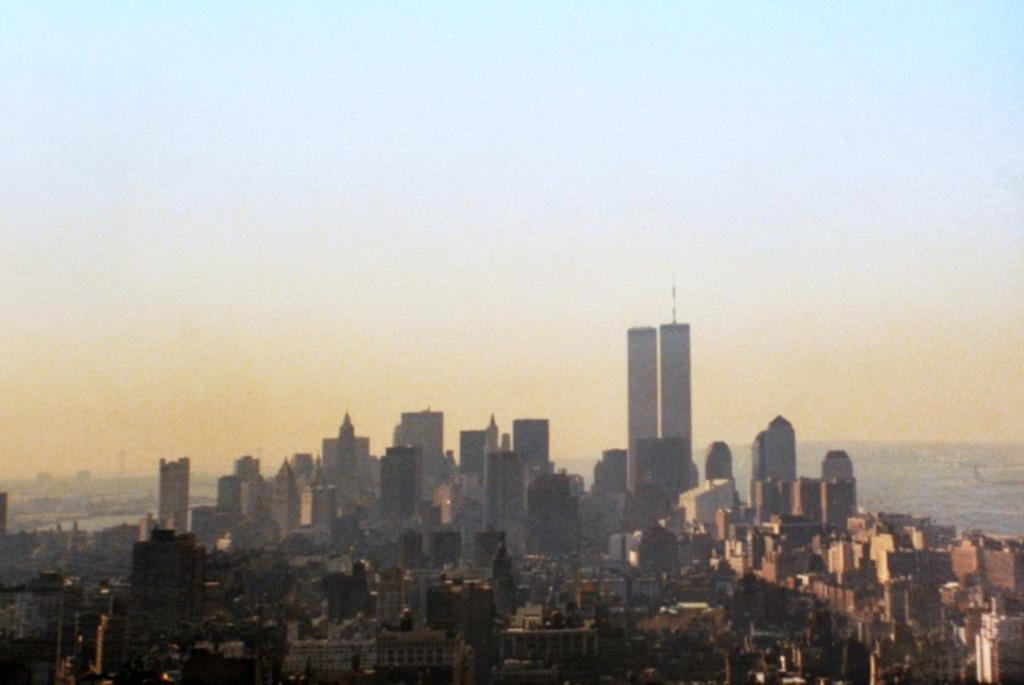What type of structures are present in the image? There are buildings in the image. What can be seen on the right side of the image? There appears to be water on the right side of the image. What is visible at the top of the image? The sky is visible at the top of the image. How does the crowd affect the buildings in the image? There is no crowd present in the image, so it cannot affect the buildings. What type of house is visible in the image? There is no house mentioned in the facts, so we cannot determine the type of house in the image. 